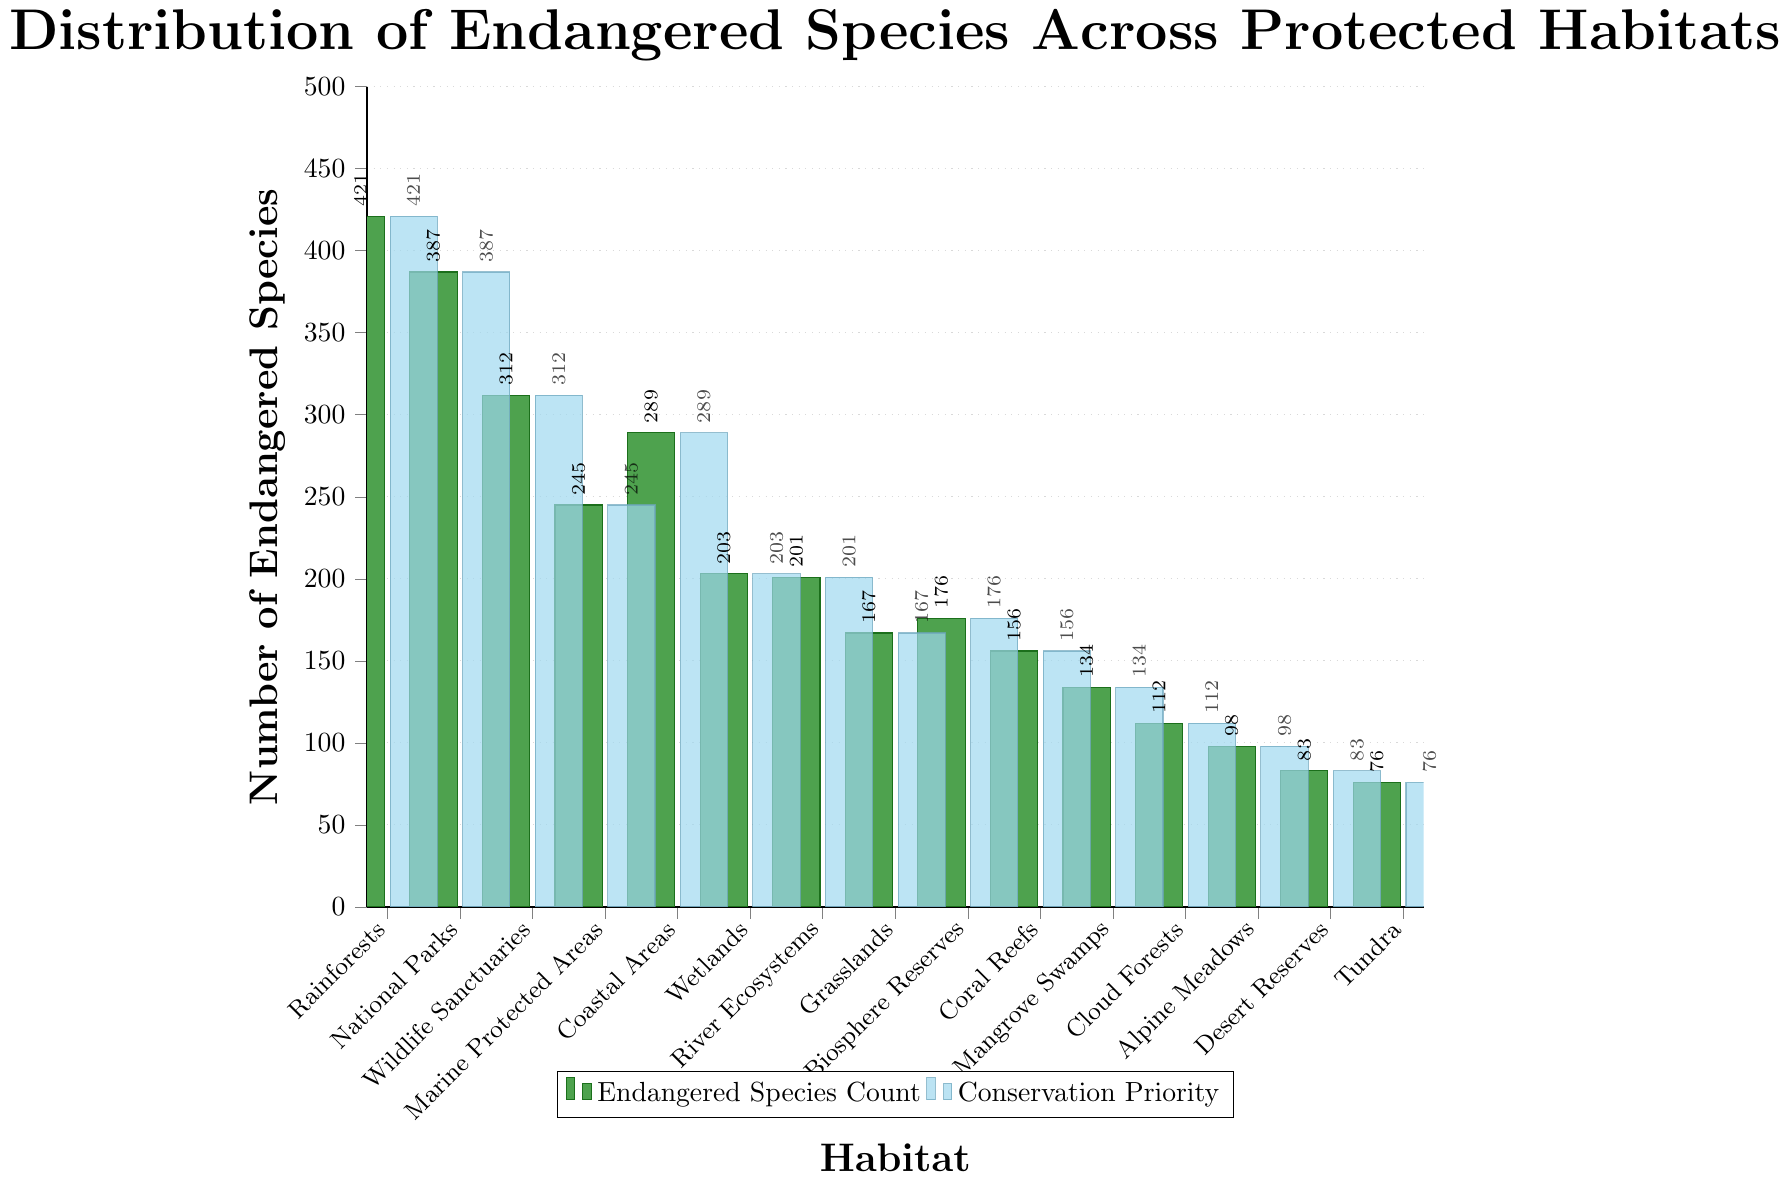What is the habitat with the highest number of endangered species? The tallest bar represents the habitat with the highest number of endangered species. By examining the heights of the bars, we identify that "Rainforests" has the tallest bar, indicating the highest number of endangered species.
Answer: Rainforests How many more endangered species are in Rainforests compared to Coral Reefs? The number of endangered species in Rainforests is 421 and in Coral Reefs is 156. Subtracting these two numbers gives us the difference: 421 - 156 = 265.
Answer: 265 What is the average number of endangered species across all habitats? To find the average, sum the number of endangered species across all habitats and divide by the number of habitats. The sum is (421 + 387 + 312 + 245 + 289 + 203 + 201 + 167 + 176 + 156 + 134 + 112 + 98 + 83 + 76) = 3460. There are 15 habitats, so the average is 3460 / 15 ≈ 230.67.
Answer: 230.67 Are there more endangered species in National Parks or Wildlife Sanctuaries? Compare the heights of the bars for National Parks and Wildlife Sanctuaries. The bar for National Parks has 387 endangered species, while Wildlife Sanctuaries has 312. Since 387 is greater than 312, National Parks have more endangered species.
Answer: National Parks Which habitats have fewer than 100 endangered species? Identify the bars whose heights are below 100. The habitats Alpine Meadows (98), Desert Reserves (83), and Tundra (76) have fewer than 100 endangered species.
Answer: Alpine Meadows, Desert Reserves, Tundra What is the total number of endangered species in Biosphere Reserves and Wetlands combined? Add the number of endangered species in Biosphere Reserves (176) and Wetlands (203): 176 + 203 = 379.
Answer: 379 Which habitat has the lowest number of endangered species? The shortest bar represents the habitat with the lowest number of endangered species. Tundra, with 76 endangered species, has the shortest bar.
Answer: Tundra Are the number of endangered species in Coastal Areas greater than or equal to those in Marine Protected Areas? Compare the number of endangered species in Coastal Areas (289) and Marine Protected Areas (245). Since 289 is greater than 245, Coastal Areas have a greater number of endangered species.
Answer: Yes What is the median number of endangered species across all habitats? First, list the number of endangered species in ascending order: 76, 83, 98, 112, 134, 156, 167, 176, 201, 203, 245, 289, 312, 387, 421. The median is the middle value in this list, which is the 8th value: 176.
Answer: 176 Which habitats have a number of endangered species between 200 and 300 inclusive? Identify the bars whose heights fall within the range of 200 to 300. These habitats are Marine Protected Areas (245), Wetlands (203), River Ecosystems (201), and Coastal Areas (289).
Answer: Marine Protected Areas, Wetlands, River Ecosystems, Coastal Areas 